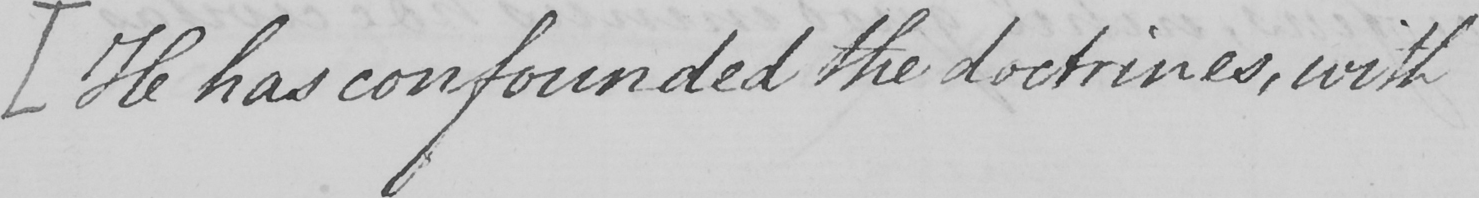What text is written in this handwritten line? [ He has confounded the doctrines , with 